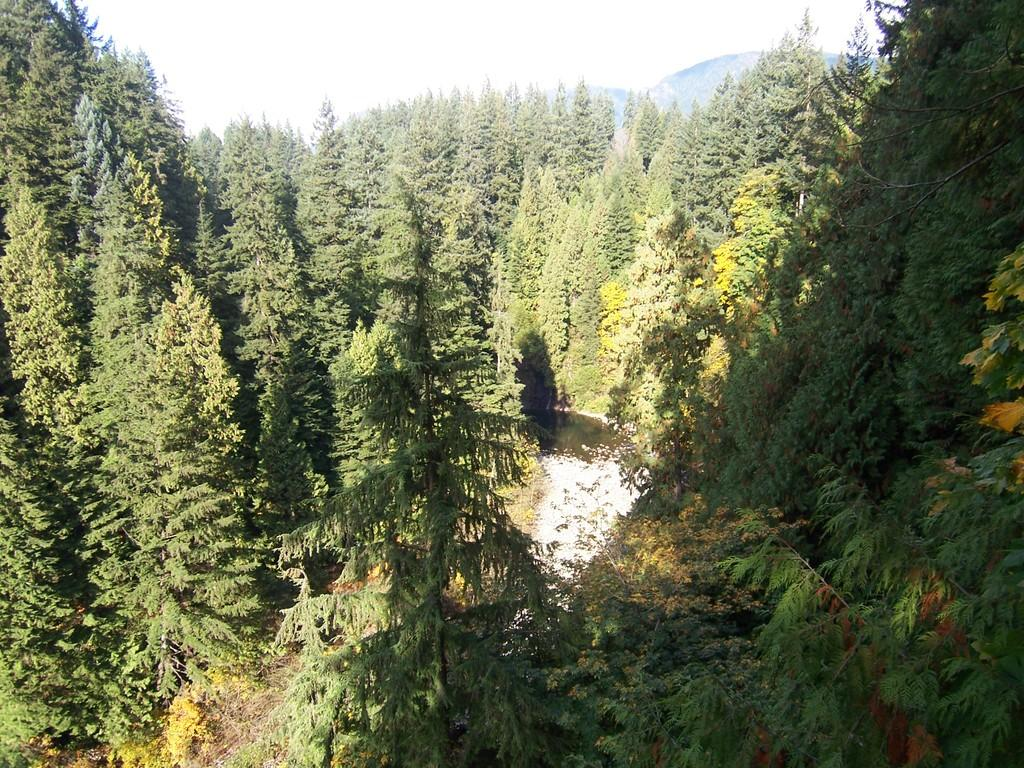Who or what can be seen in the image? There are people in the image. What is located in the center of the image? There is a canal in the center of the image. What is visible at the top of the image? The sky is visible at the top of the image. What type of natural feature can be seen in the image? There are hills in the image. What type of hole can be seen in the image? There is no hole present in the image. How do the people in the image show respect to each other? The image does not provide information about how the people are interacting or showing respect to each other. 